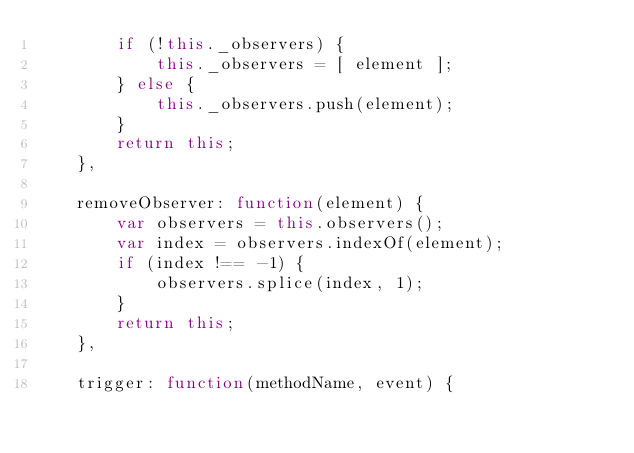Convert code to text. <code><loc_0><loc_0><loc_500><loc_500><_JavaScript_>        if (!this._observers) {
            this._observers = [ element ];
        } else {
            this._observers.push(element);
        }
        return this;
    },

    removeObserver: function(element) {
        var observers = this.observers();
        var index = observers.indexOf(element);
        if (index !== -1) {
            observers.splice(index, 1);
        }
        return this;
    },

    trigger: function(methodName, event) {</code> 